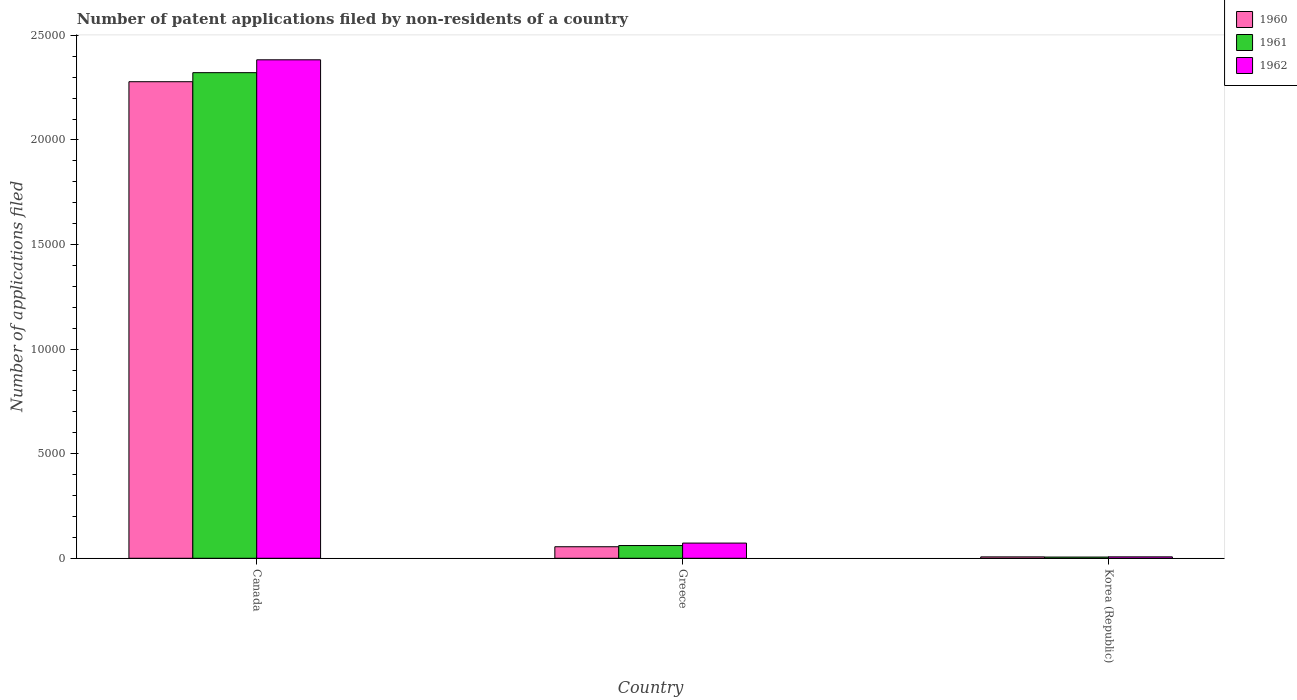How many bars are there on the 1st tick from the left?
Offer a very short reply. 3. How many bars are there on the 1st tick from the right?
Provide a short and direct response. 3. What is the number of applications filed in 1960 in Korea (Republic)?
Your answer should be compact. 66. Across all countries, what is the maximum number of applications filed in 1960?
Your response must be concise. 2.28e+04. Across all countries, what is the minimum number of applications filed in 1961?
Your answer should be compact. 58. In which country was the number of applications filed in 1961 maximum?
Your answer should be very brief. Canada. In which country was the number of applications filed in 1960 minimum?
Your response must be concise. Korea (Republic). What is the total number of applications filed in 1960 in the graph?
Your answer should be very brief. 2.34e+04. What is the difference between the number of applications filed in 1962 in Greece and that in Korea (Republic)?
Keep it short and to the point. 658. What is the difference between the number of applications filed in 1961 in Canada and the number of applications filed in 1960 in Greece?
Offer a terse response. 2.27e+04. What is the average number of applications filed in 1960 per country?
Your answer should be compact. 7801. What is the difference between the number of applications filed of/in 1960 and number of applications filed of/in 1962 in Canada?
Your answer should be compact. -1048. What is the ratio of the number of applications filed in 1961 in Canada to that in Greece?
Offer a terse response. 38.13. Is the number of applications filed in 1960 in Canada less than that in Greece?
Keep it short and to the point. No. Is the difference between the number of applications filed in 1960 in Greece and Korea (Republic) greater than the difference between the number of applications filed in 1962 in Greece and Korea (Republic)?
Keep it short and to the point. No. What is the difference between the highest and the second highest number of applications filed in 1960?
Offer a terse response. 2.27e+04. What is the difference between the highest and the lowest number of applications filed in 1960?
Provide a succinct answer. 2.27e+04. What does the 2nd bar from the left in Canada represents?
Make the answer very short. 1961. Is it the case that in every country, the sum of the number of applications filed in 1962 and number of applications filed in 1961 is greater than the number of applications filed in 1960?
Offer a terse response. Yes. How many bars are there?
Offer a very short reply. 9. Are all the bars in the graph horizontal?
Make the answer very short. No. What is the difference between two consecutive major ticks on the Y-axis?
Ensure brevity in your answer.  5000. Does the graph contain any zero values?
Offer a terse response. No. Does the graph contain grids?
Your answer should be very brief. No. How are the legend labels stacked?
Your answer should be very brief. Vertical. What is the title of the graph?
Keep it short and to the point. Number of patent applications filed by non-residents of a country. Does "1992" appear as one of the legend labels in the graph?
Ensure brevity in your answer.  No. What is the label or title of the Y-axis?
Give a very brief answer. Number of applications filed. What is the Number of applications filed of 1960 in Canada?
Ensure brevity in your answer.  2.28e+04. What is the Number of applications filed of 1961 in Canada?
Ensure brevity in your answer.  2.32e+04. What is the Number of applications filed of 1962 in Canada?
Your answer should be very brief. 2.38e+04. What is the Number of applications filed in 1960 in Greece?
Your response must be concise. 551. What is the Number of applications filed in 1961 in Greece?
Your response must be concise. 609. What is the Number of applications filed of 1962 in Greece?
Offer a terse response. 726. What is the Number of applications filed of 1960 in Korea (Republic)?
Offer a very short reply. 66. What is the Number of applications filed of 1962 in Korea (Republic)?
Provide a succinct answer. 68. Across all countries, what is the maximum Number of applications filed in 1960?
Provide a succinct answer. 2.28e+04. Across all countries, what is the maximum Number of applications filed of 1961?
Your answer should be compact. 2.32e+04. Across all countries, what is the maximum Number of applications filed in 1962?
Your response must be concise. 2.38e+04. Across all countries, what is the minimum Number of applications filed in 1960?
Offer a terse response. 66. Across all countries, what is the minimum Number of applications filed in 1961?
Provide a succinct answer. 58. What is the total Number of applications filed of 1960 in the graph?
Your answer should be compact. 2.34e+04. What is the total Number of applications filed of 1961 in the graph?
Ensure brevity in your answer.  2.39e+04. What is the total Number of applications filed in 1962 in the graph?
Provide a short and direct response. 2.46e+04. What is the difference between the Number of applications filed of 1960 in Canada and that in Greece?
Your answer should be compact. 2.22e+04. What is the difference between the Number of applications filed of 1961 in Canada and that in Greece?
Offer a very short reply. 2.26e+04. What is the difference between the Number of applications filed of 1962 in Canada and that in Greece?
Ensure brevity in your answer.  2.31e+04. What is the difference between the Number of applications filed of 1960 in Canada and that in Korea (Republic)?
Your answer should be compact. 2.27e+04. What is the difference between the Number of applications filed of 1961 in Canada and that in Korea (Republic)?
Give a very brief answer. 2.32e+04. What is the difference between the Number of applications filed in 1962 in Canada and that in Korea (Republic)?
Offer a terse response. 2.38e+04. What is the difference between the Number of applications filed in 1960 in Greece and that in Korea (Republic)?
Your response must be concise. 485. What is the difference between the Number of applications filed of 1961 in Greece and that in Korea (Republic)?
Your answer should be compact. 551. What is the difference between the Number of applications filed in 1962 in Greece and that in Korea (Republic)?
Your answer should be compact. 658. What is the difference between the Number of applications filed of 1960 in Canada and the Number of applications filed of 1961 in Greece?
Your response must be concise. 2.22e+04. What is the difference between the Number of applications filed in 1960 in Canada and the Number of applications filed in 1962 in Greece?
Offer a very short reply. 2.21e+04. What is the difference between the Number of applications filed in 1961 in Canada and the Number of applications filed in 1962 in Greece?
Provide a short and direct response. 2.25e+04. What is the difference between the Number of applications filed in 1960 in Canada and the Number of applications filed in 1961 in Korea (Republic)?
Keep it short and to the point. 2.27e+04. What is the difference between the Number of applications filed in 1960 in Canada and the Number of applications filed in 1962 in Korea (Republic)?
Give a very brief answer. 2.27e+04. What is the difference between the Number of applications filed of 1961 in Canada and the Number of applications filed of 1962 in Korea (Republic)?
Provide a short and direct response. 2.32e+04. What is the difference between the Number of applications filed in 1960 in Greece and the Number of applications filed in 1961 in Korea (Republic)?
Make the answer very short. 493. What is the difference between the Number of applications filed in 1960 in Greece and the Number of applications filed in 1962 in Korea (Republic)?
Make the answer very short. 483. What is the difference between the Number of applications filed in 1961 in Greece and the Number of applications filed in 1962 in Korea (Republic)?
Offer a terse response. 541. What is the average Number of applications filed of 1960 per country?
Your response must be concise. 7801. What is the average Number of applications filed of 1961 per country?
Make the answer very short. 7962. What is the average Number of applications filed of 1962 per country?
Give a very brief answer. 8209.33. What is the difference between the Number of applications filed in 1960 and Number of applications filed in 1961 in Canada?
Offer a terse response. -433. What is the difference between the Number of applications filed of 1960 and Number of applications filed of 1962 in Canada?
Offer a terse response. -1048. What is the difference between the Number of applications filed in 1961 and Number of applications filed in 1962 in Canada?
Make the answer very short. -615. What is the difference between the Number of applications filed of 1960 and Number of applications filed of 1961 in Greece?
Your response must be concise. -58. What is the difference between the Number of applications filed of 1960 and Number of applications filed of 1962 in Greece?
Provide a succinct answer. -175. What is the difference between the Number of applications filed in 1961 and Number of applications filed in 1962 in Greece?
Provide a short and direct response. -117. What is the difference between the Number of applications filed of 1960 and Number of applications filed of 1962 in Korea (Republic)?
Offer a terse response. -2. What is the difference between the Number of applications filed of 1961 and Number of applications filed of 1962 in Korea (Republic)?
Provide a short and direct response. -10. What is the ratio of the Number of applications filed in 1960 in Canada to that in Greece?
Make the answer very short. 41.35. What is the ratio of the Number of applications filed in 1961 in Canada to that in Greece?
Keep it short and to the point. 38.13. What is the ratio of the Number of applications filed of 1962 in Canada to that in Greece?
Ensure brevity in your answer.  32.83. What is the ratio of the Number of applications filed of 1960 in Canada to that in Korea (Republic)?
Ensure brevity in your answer.  345.24. What is the ratio of the Number of applications filed in 1961 in Canada to that in Korea (Republic)?
Keep it short and to the point. 400.33. What is the ratio of the Number of applications filed of 1962 in Canada to that in Korea (Republic)?
Keep it short and to the point. 350.5. What is the ratio of the Number of applications filed in 1960 in Greece to that in Korea (Republic)?
Offer a very short reply. 8.35. What is the ratio of the Number of applications filed in 1962 in Greece to that in Korea (Republic)?
Give a very brief answer. 10.68. What is the difference between the highest and the second highest Number of applications filed of 1960?
Ensure brevity in your answer.  2.22e+04. What is the difference between the highest and the second highest Number of applications filed in 1961?
Ensure brevity in your answer.  2.26e+04. What is the difference between the highest and the second highest Number of applications filed of 1962?
Offer a very short reply. 2.31e+04. What is the difference between the highest and the lowest Number of applications filed in 1960?
Keep it short and to the point. 2.27e+04. What is the difference between the highest and the lowest Number of applications filed of 1961?
Make the answer very short. 2.32e+04. What is the difference between the highest and the lowest Number of applications filed of 1962?
Your answer should be compact. 2.38e+04. 